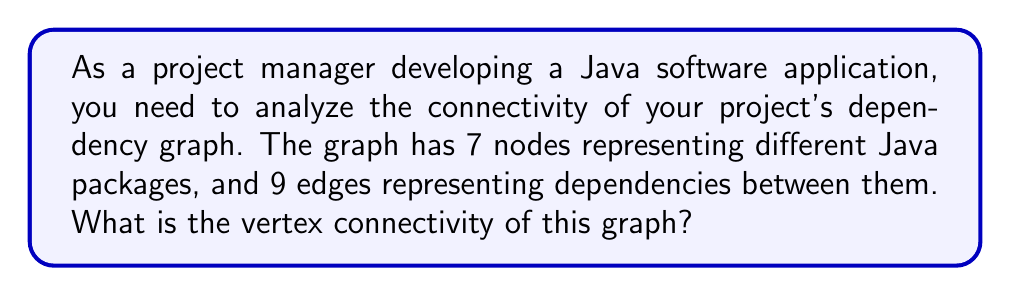Could you help me with this problem? To solve this problem, we need to understand the concept of vertex connectivity in graph theory and how it applies to software dependencies.

1. Vertex connectivity definition:
   The vertex connectivity of a graph, denoted as $\kappa(G)$, is the minimum number of vertices that need to be removed to disconnect the graph.

2. For our software dependency graph:
   - We have 7 nodes (packages)
   - We have 9 edges (dependencies)

3. To find the vertex connectivity, we need to consider:
   a) The minimum degree of the graph, $\delta(G)$
   b) The number of vertices, $n$

4. In a graph with $n$ vertices, the vertex connectivity is always less than or equal to the minimum degree:

   $$\kappa(G) \leq \delta(G) \leq n - 1$$

5. Without knowing the exact structure of the graph, we can make some observations:
   - The average degree of the graph is $\frac{2|E|}{|V|} = \frac{2 * 9}{7} \approx 2.57$
   - This suggests that the minimum degree is likely to be 2 or 3

6. In a software dependency context, vertex connectivity represents the minimum number of packages that, if removed, would break the project into disconnected components.

7. Given the relatively small number of packages and dependencies, and considering typical software architectures, it's reasonable to assume that removing 1 or 2 key packages could disconnect the graph.

8. Therefore, the most likely value for the vertex connectivity in this scenario is 1 or 2.

9. Without more specific information about the graph structure, we'll assume the lower value of 1, which represents a single critical package that, if removed, would disconnect the dependency graph.
Answer: $\kappa(G) = 1$ 